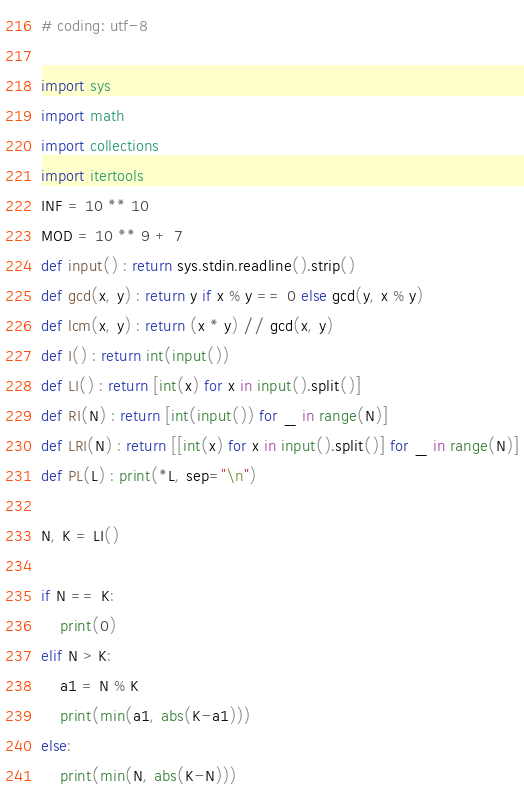Convert code to text. <code><loc_0><loc_0><loc_500><loc_500><_Python_># coding: utf-8

import sys
import math
import collections
import itertools
INF = 10 ** 10
MOD = 10 ** 9 + 7
def input() : return sys.stdin.readline().strip()
def gcd(x, y) : return y if x % y == 0 else gcd(y, x % y)
def lcm(x, y) : return (x * y) // gcd(x, y)
def I() : return int(input())
def LI() : return [int(x) for x in input().split()]
def RI(N) : return [int(input()) for _ in range(N)]
def LRI(N) : return [[int(x) for x in input().split()] for _ in range(N)]
def PL(L) : print(*L, sep="\n")

N, K = LI()

if N == K:
    print(0)
elif N > K:
    a1 = N % K
    print(min(a1, abs(K-a1)))
else:
    print(min(N, abs(K-N)))
</code> 